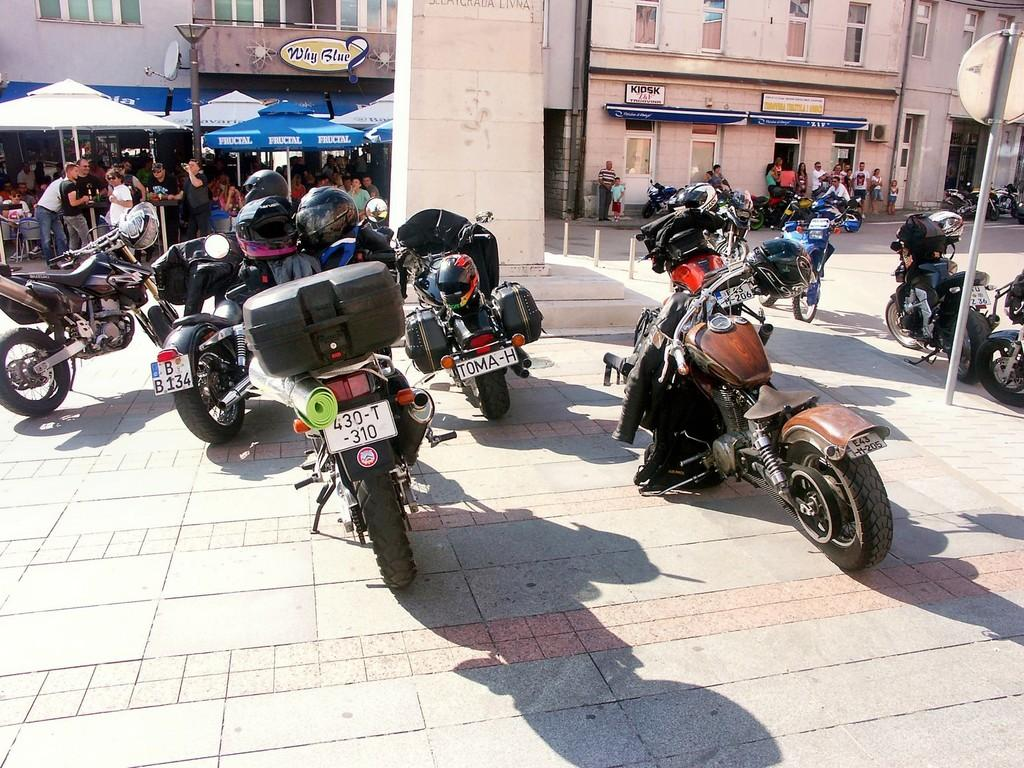What type of structures can be seen in the image? There are buildings in the image. What objects are present to control or guide traffic? Barrier rods, a light pole, and a sign board pole are visible in the image. What type of temporary shelter is available in the image? Tents for shelter are in the image. Are there any people in the image? Yes, people are present in the image. What mode of transportation can be seen in the image? Vehicles are visible in the image. What type of pathways are available in the image? There is a road and a path present in the image. What type of crate is being used to store grain in the image? There is no crate or grain present in the image. How many parcels can be seen being delivered in the image? There are no parcels or delivery activities depicted in the image. 